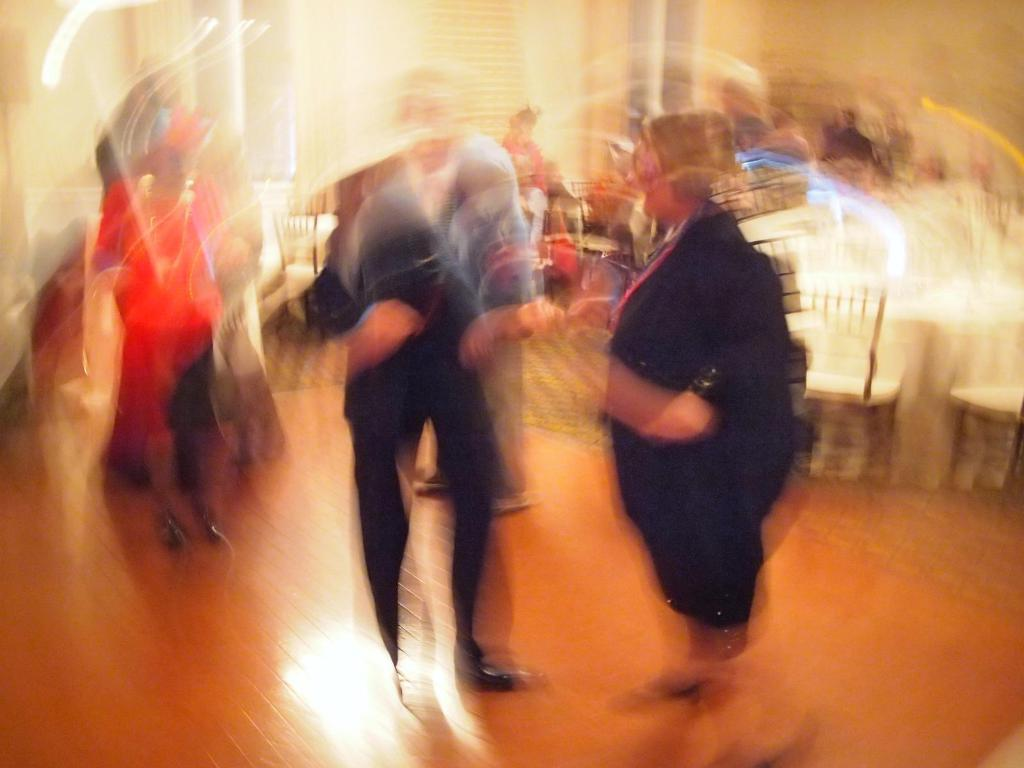What are the people in the image doing? The people in the image are standing on the floor. What furniture can be seen in the image? Chairs are visible in the image. What is in the background of the image? There is a wall in the background of the image. What type of smoke can be seen coming from the cars in the image? There are no cars or smoke present in the image. 